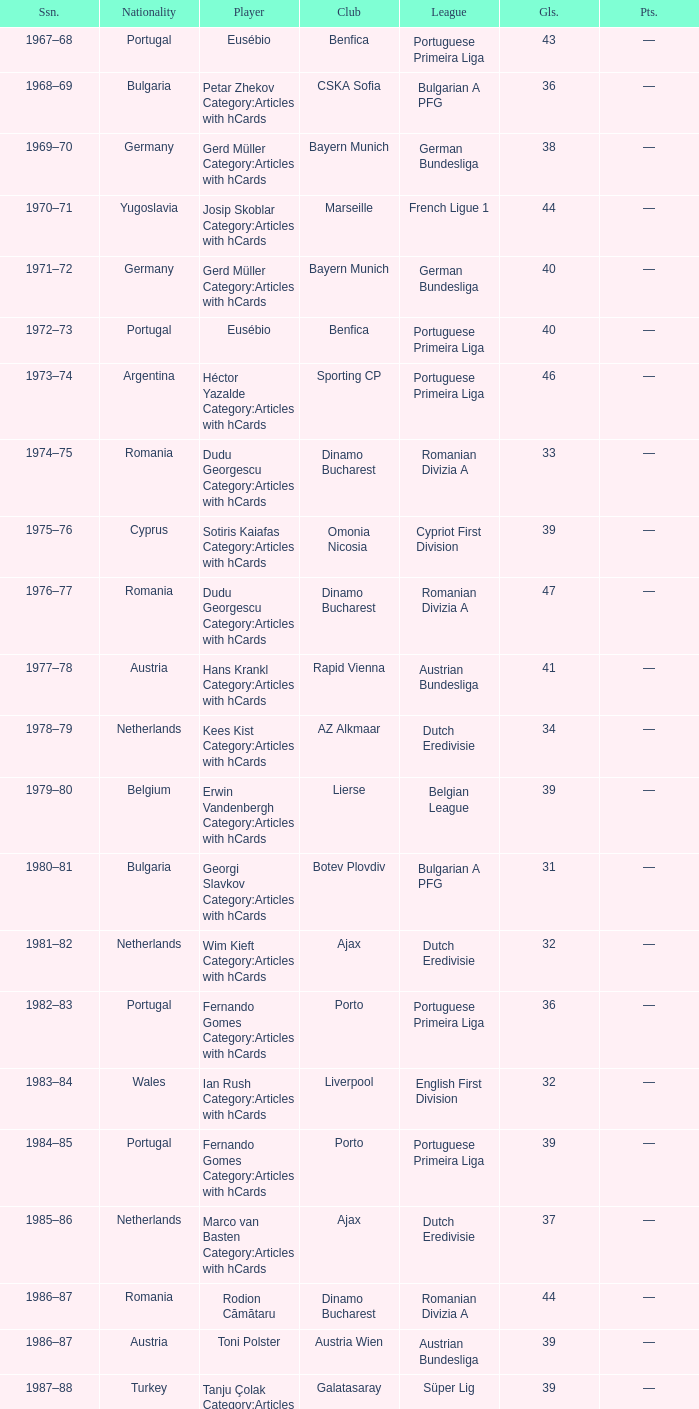Which player was in the Omonia Nicosia club? Sotiris Kaiafas Category:Articles with hCards. 